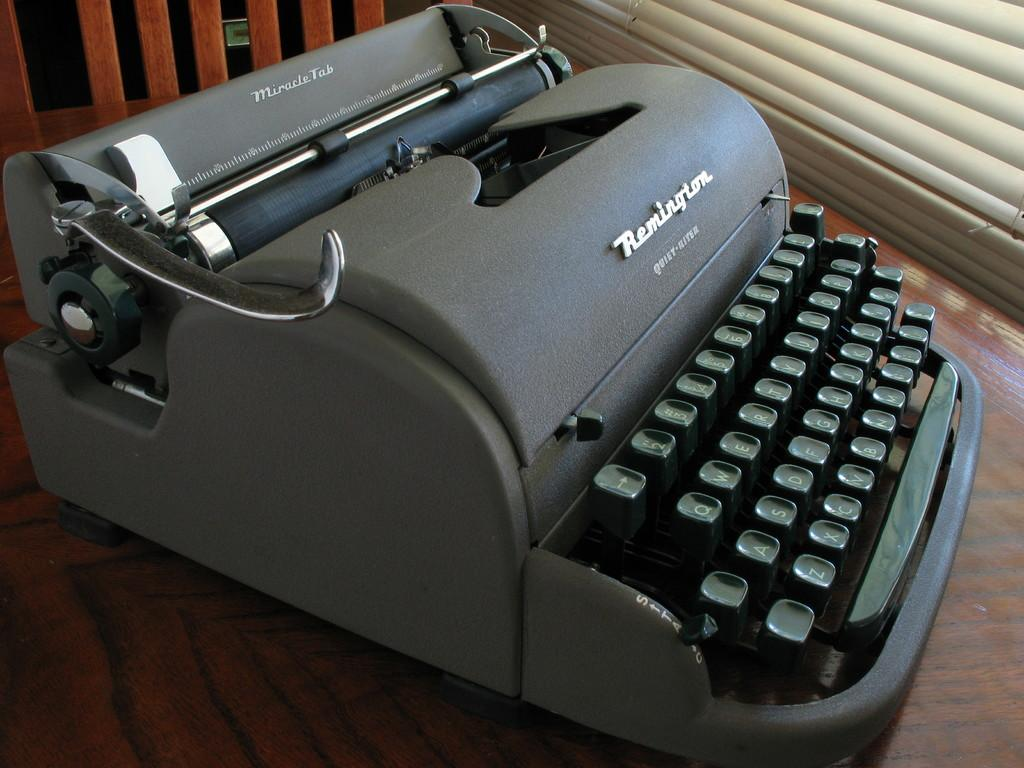Provide a one-sentence caption for the provided image. Remington type writer of an old fashioned style and raised keys. 